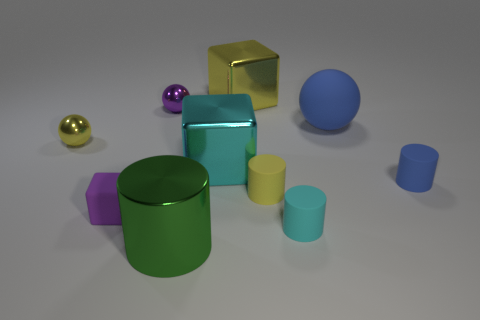There is a blue rubber sphere; what number of small cyan rubber cylinders are behind it?
Offer a terse response. 0. What shape is the yellow thing that is left of the large object behind the purple metallic object?
Offer a terse response. Sphere. There is a large yellow object that is made of the same material as the green thing; what shape is it?
Offer a very short reply. Cube. There is a metallic block that is in front of the tiny yellow ball; does it have the same size as the cyan cylinder that is right of the cyan cube?
Ensure brevity in your answer.  No. What shape is the tiny object that is on the right side of the small cyan rubber cylinder?
Keep it short and to the point. Cylinder. What is the color of the rubber block?
Ensure brevity in your answer.  Purple. There is a green object; does it have the same size as the cyan thing left of the big yellow metallic block?
Make the answer very short. Yes. What number of rubber things are red objects or large cyan things?
Offer a very short reply. 0. There is a big sphere; does it have the same color as the rubber cylinder to the right of the small cyan thing?
Make the answer very short. Yes. What is the shape of the purple rubber object?
Keep it short and to the point. Cube. 